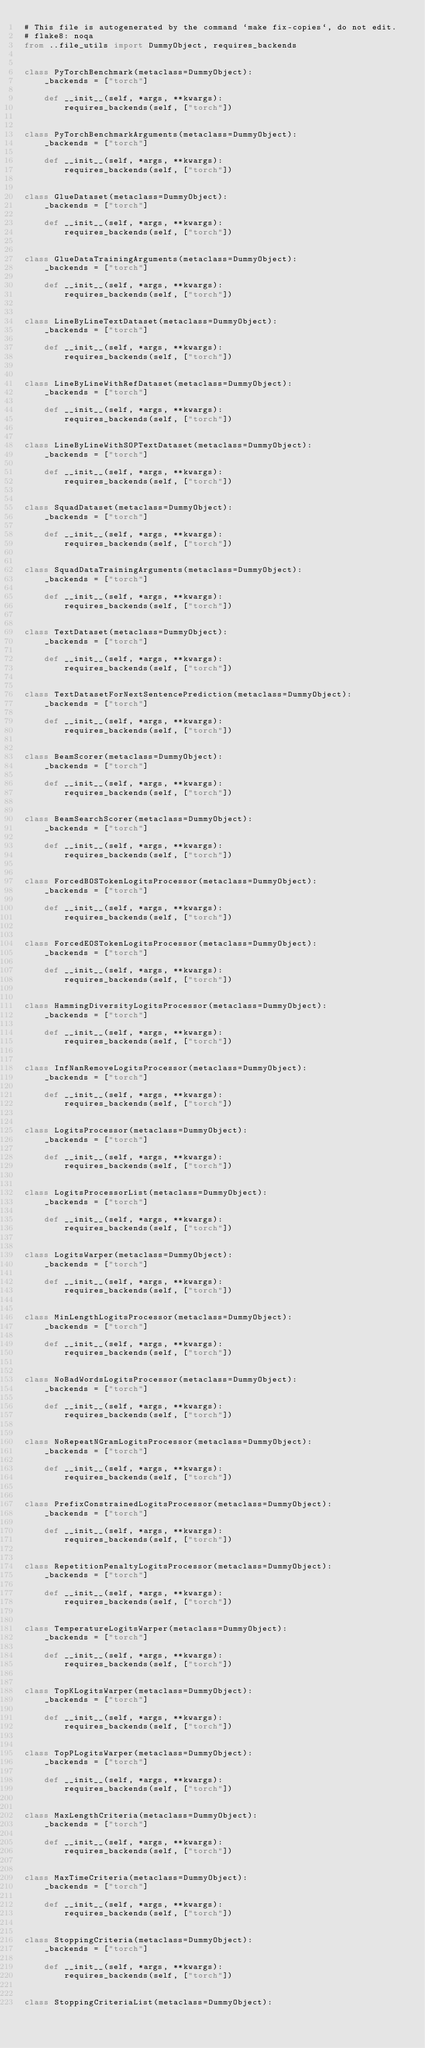Convert code to text. <code><loc_0><loc_0><loc_500><loc_500><_Python_># This file is autogenerated by the command `make fix-copies`, do not edit.
# flake8: noqa
from ..file_utils import DummyObject, requires_backends


class PyTorchBenchmark(metaclass=DummyObject):
    _backends = ["torch"]

    def __init__(self, *args, **kwargs):
        requires_backends(self, ["torch"])


class PyTorchBenchmarkArguments(metaclass=DummyObject):
    _backends = ["torch"]

    def __init__(self, *args, **kwargs):
        requires_backends(self, ["torch"])


class GlueDataset(metaclass=DummyObject):
    _backends = ["torch"]

    def __init__(self, *args, **kwargs):
        requires_backends(self, ["torch"])


class GlueDataTrainingArguments(metaclass=DummyObject):
    _backends = ["torch"]

    def __init__(self, *args, **kwargs):
        requires_backends(self, ["torch"])


class LineByLineTextDataset(metaclass=DummyObject):
    _backends = ["torch"]

    def __init__(self, *args, **kwargs):
        requires_backends(self, ["torch"])


class LineByLineWithRefDataset(metaclass=DummyObject):
    _backends = ["torch"]

    def __init__(self, *args, **kwargs):
        requires_backends(self, ["torch"])


class LineByLineWithSOPTextDataset(metaclass=DummyObject):
    _backends = ["torch"]

    def __init__(self, *args, **kwargs):
        requires_backends(self, ["torch"])


class SquadDataset(metaclass=DummyObject):
    _backends = ["torch"]

    def __init__(self, *args, **kwargs):
        requires_backends(self, ["torch"])


class SquadDataTrainingArguments(metaclass=DummyObject):
    _backends = ["torch"]

    def __init__(self, *args, **kwargs):
        requires_backends(self, ["torch"])


class TextDataset(metaclass=DummyObject):
    _backends = ["torch"]

    def __init__(self, *args, **kwargs):
        requires_backends(self, ["torch"])


class TextDatasetForNextSentencePrediction(metaclass=DummyObject):
    _backends = ["torch"]

    def __init__(self, *args, **kwargs):
        requires_backends(self, ["torch"])


class BeamScorer(metaclass=DummyObject):
    _backends = ["torch"]

    def __init__(self, *args, **kwargs):
        requires_backends(self, ["torch"])


class BeamSearchScorer(metaclass=DummyObject):
    _backends = ["torch"]

    def __init__(self, *args, **kwargs):
        requires_backends(self, ["torch"])


class ForcedBOSTokenLogitsProcessor(metaclass=DummyObject):
    _backends = ["torch"]

    def __init__(self, *args, **kwargs):
        requires_backends(self, ["torch"])


class ForcedEOSTokenLogitsProcessor(metaclass=DummyObject):
    _backends = ["torch"]

    def __init__(self, *args, **kwargs):
        requires_backends(self, ["torch"])


class HammingDiversityLogitsProcessor(metaclass=DummyObject):
    _backends = ["torch"]

    def __init__(self, *args, **kwargs):
        requires_backends(self, ["torch"])


class InfNanRemoveLogitsProcessor(metaclass=DummyObject):
    _backends = ["torch"]

    def __init__(self, *args, **kwargs):
        requires_backends(self, ["torch"])


class LogitsProcessor(metaclass=DummyObject):
    _backends = ["torch"]

    def __init__(self, *args, **kwargs):
        requires_backends(self, ["torch"])


class LogitsProcessorList(metaclass=DummyObject):
    _backends = ["torch"]

    def __init__(self, *args, **kwargs):
        requires_backends(self, ["torch"])


class LogitsWarper(metaclass=DummyObject):
    _backends = ["torch"]

    def __init__(self, *args, **kwargs):
        requires_backends(self, ["torch"])


class MinLengthLogitsProcessor(metaclass=DummyObject):
    _backends = ["torch"]

    def __init__(self, *args, **kwargs):
        requires_backends(self, ["torch"])


class NoBadWordsLogitsProcessor(metaclass=DummyObject):
    _backends = ["torch"]

    def __init__(self, *args, **kwargs):
        requires_backends(self, ["torch"])


class NoRepeatNGramLogitsProcessor(metaclass=DummyObject):
    _backends = ["torch"]

    def __init__(self, *args, **kwargs):
        requires_backends(self, ["torch"])


class PrefixConstrainedLogitsProcessor(metaclass=DummyObject):
    _backends = ["torch"]

    def __init__(self, *args, **kwargs):
        requires_backends(self, ["torch"])


class RepetitionPenaltyLogitsProcessor(metaclass=DummyObject):
    _backends = ["torch"]

    def __init__(self, *args, **kwargs):
        requires_backends(self, ["torch"])


class TemperatureLogitsWarper(metaclass=DummyObject):
    _backends = ["torch"]

    def __init__(self, *args, **kwargs):
        requires_backends(self, ["torch"])


class TopKLogitsWarper(metaclass=DummyObject):
    _backends = ["torch"]

    def __init__(self, *args, **kwargs):
        requires_backends(self, ["torch"])


class TopPLogitsWarper(metaclass=DummyObject):
    _backends = ["torch"]

    def __init__(self, *args, **kwargs):
        requires_backends(self, ["torch"])


class MaxLengthCriteria(metaclass=DummyObject):
    _backends = ["torch"]

    def __init__(self, *args, **kwargs):
        requires_backends(self, ["torch"])


class MaxTimeCriteria(metaclass=DummyObject):
    _backends = ["torch"]

    def __init__(self, *args, **kwargs):
        requires_backends(self, ["torch"])


class StoppingCriteria(metaclass=DummyObject):
    _backends = ["torch"]

    def __init__(self, *args, **kwargs):
        requires_backends(self, ["torch"])


class StoppingCriteriaList(metaclass=DummyObject):</code> 